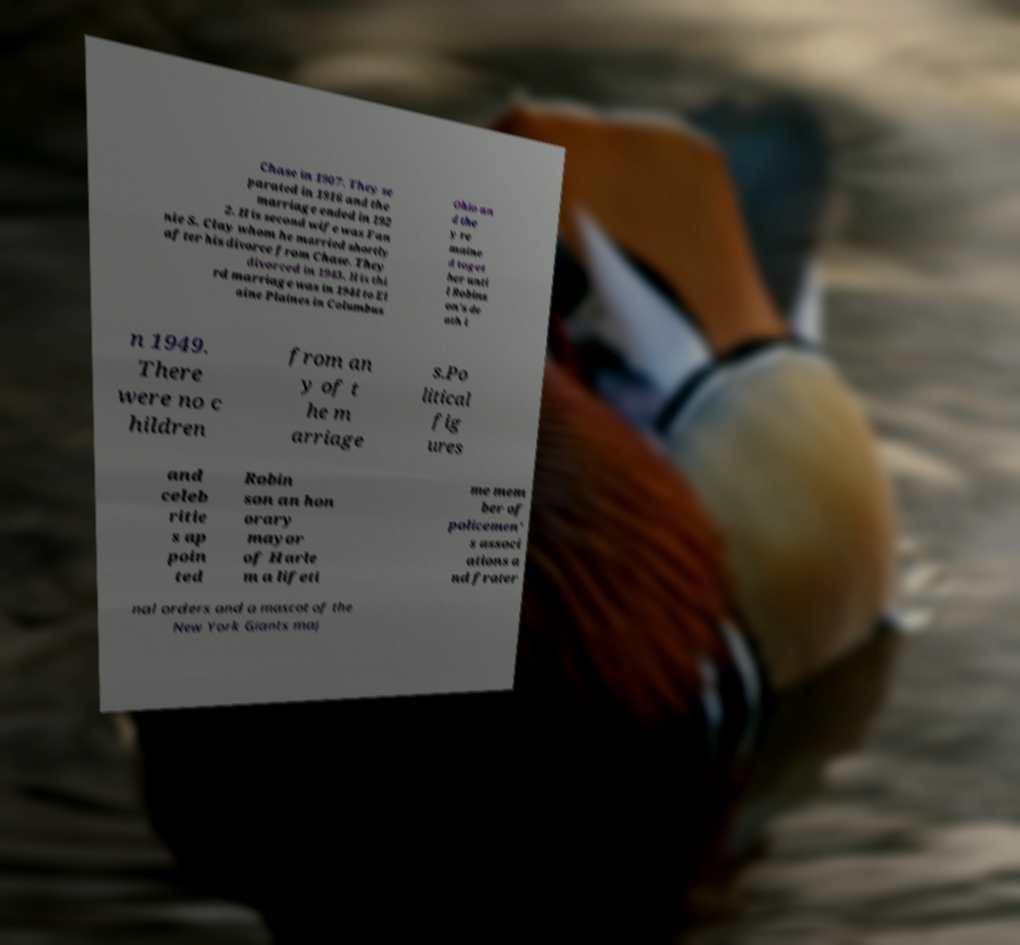Could you assist in decoding the text presented in this image and type it out clearly? Chase in 1907. They se parated in 1916 and the marriage ended in 192 2. His second wife was Fan nie S. Clay whom he married shortly after his divorce from Chase. They divorced in 1943. His thi rd marriage was in 1944 to El aine Plaines in Columbus Ohio an d the y re maine d toget her unti l Robins on's de ath i n 1949. There were no c hildren from an y of t he m arriage s.Po litical fig ures and celeb ritie s ap poin ted Robin son an hon orary mayor of Harle m a lifeti me mem ber of policemen' s associ ations a nd frater nal orders and a mascot of the New York Giants maj 